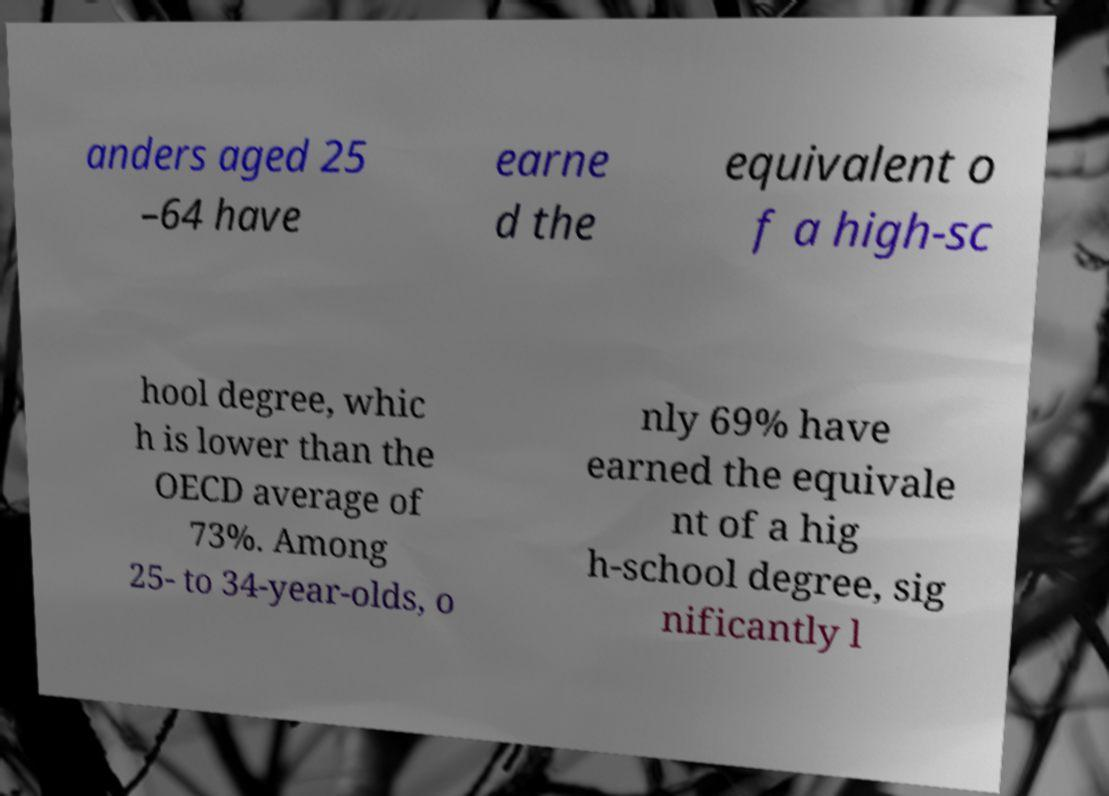Can you read and provide the text displayed in the image?This photo seems to have some interesting text. Can you extract and type it out for me? anders aged 25 –64 have earne d the equivalent o f a high-sc hool degree, whic h is lower than the OECD average of 73%. Among 25- to 34-year-olds, o nly 69% have earned the equivale nt of a hig h-school degree, sig nificantly l 